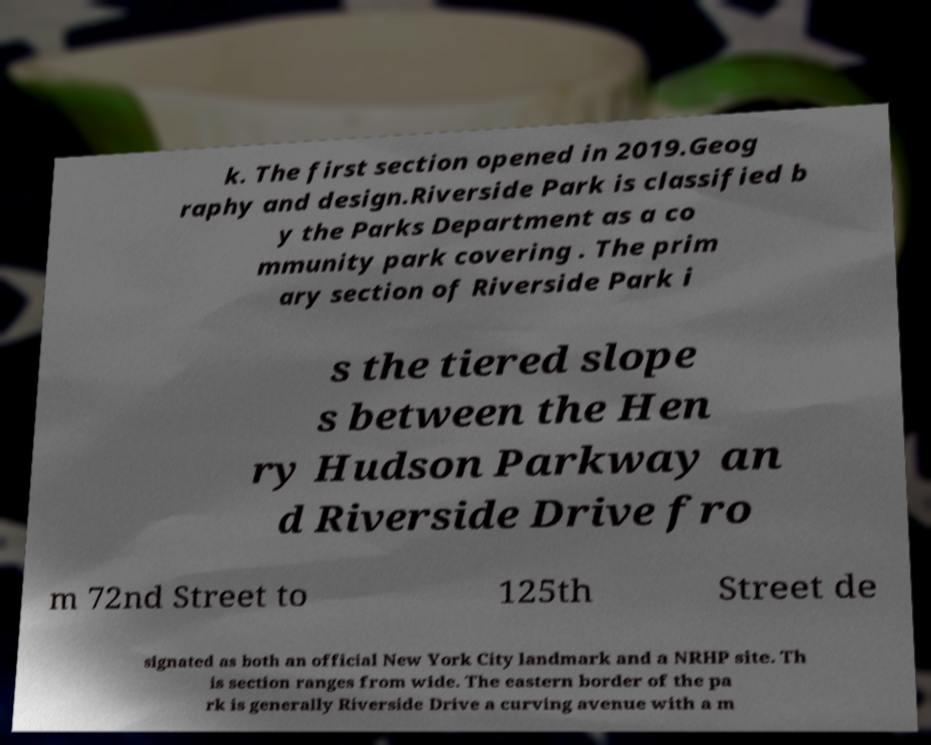What messages or text are displayed in this image? I need them in a readable, typed format. k. The first section opened in 2019.Geog raphy and design.Riverside Park is classified b y the Parks Department as a co mmunity park covering . The prim ary section of Riverside Park i s the tiered slope s between the Hen ry Hudson Parkway an d Riverside Drive fro m 72nd Street to 125th Street de signated as both an official New York City landmark and a NRHP site. Th is section ranges from wide. The eastern border of the pa rk is generally Riverside Drive a curving avenue with a m 